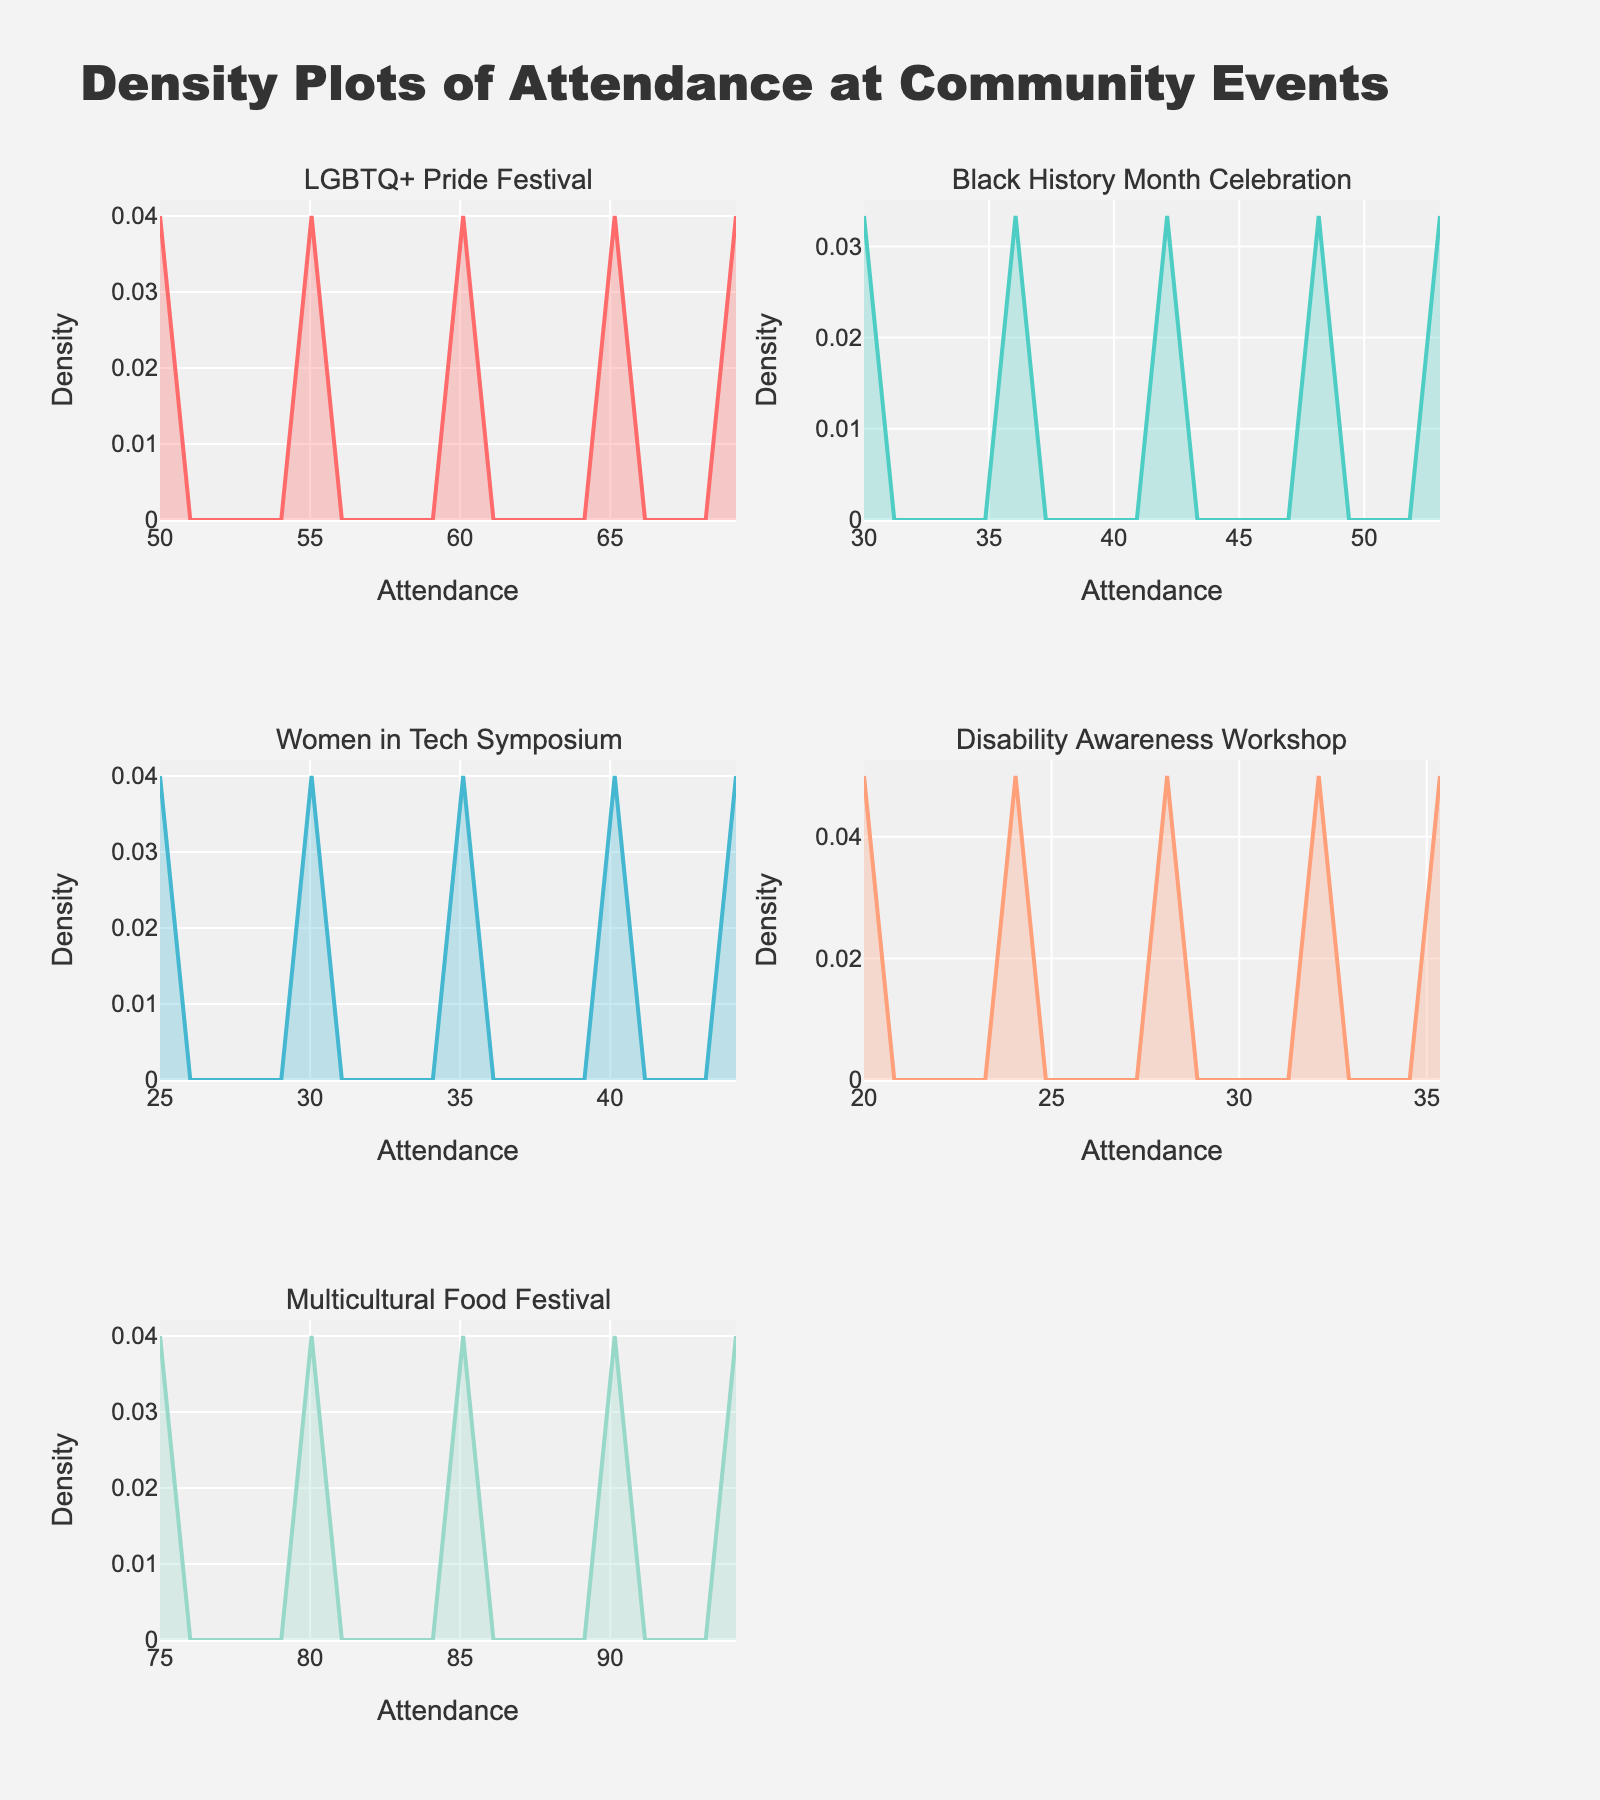What is the title of the figure? The title of the figure is shown at the top of the image, and it reads "Density Plots of Attendance at Community Events".
Answer: Density Plots of Attendance at Community Events What is the range of attendance values for the Disability Awareness Workshop? The x-axis range for the Disability Awareness Workshop plot shows attendance values from 20 to 100. This information can be observed by looking at the minimum and maximum values on the x-axis of the subplot.
Answer: 20 to 100 Which event has the highest density peak? To determine the highest density peak, we need to look at the y-axes of all the subplots and identify the one with the highest peak. The LGBTQ+ Pride Festival has the highest density peak because its y-axis reaches higher than others.
Answer: LGBTQ+ Pride Festival How does the density of attendance at the Multicultural Food Festival compare to the Women in Tech Symposium? Comparing the density curves of both events, the density peak for the Multicultural Food Festival is higher and broader compared to the Women in Tech Symposium, indicating a higher concentration of events with larger attendances.
Answer: Multicultural Food Festival has higher and broader density peak What is the approximate attendance value where the highest density occurs for the LGBTQ+ Pride Festival? The highest density peak for the LGBTQ+ Pride Festival occurs at an x-value, i.e., attendance, of approximately 100. We identify this by looking at the highest point on the density curve and tracing it down to the x-axis.
Answer: 100 Are the attendance patterns in Black History Month Celebration and Disability Awareness Workshop similar? By comparing the shapes and peaks of the density curves for both events, we can see that they are different. The Black History Month Celebration has a more spread-out distribution with peaks around 30, 60, and 90, while the Disability Awareness Workshop shows a peak around 60 and a more concentrated distribution.
Answer: No Which event shows a more uniform distribution of attendance? A more uniform distribution would have similar density values across all attendance ranges. The Density plot for the Black History Month Celebration has peaks spread more evenly across different attendance values, indicating a more uniform distribution.
Answer: Black History Month Celebration Which event has the lowest maximum attendance? By examining the x-axes of all subplots, the Disability Awareness Workshop has the lowest maximum attendance value, which is 100.
Answer: Disability Awareness Workshop How does the density curve of attendance at the Women's Tech Symposium change as attendance increases? The density curve starts with a peak at lower attendance values and gradually decreases as the attendance increases, indicating fewer events with higher attendance for the Women's Tech Symposium.
Answer: Decreases as attendance increases What is the main insight you can derive from the density plot for Multicultural Food Festival? The main insight is that the Multicultural Food Festival tends to have higher attendance, as indicated by the broader and high density peak at higher attendance values (125 to 175), showing events often have large crowds.
Answer: Higher attendance, larger crowds 